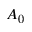Convert formula to latex. <formula><loc_0><loc_0><loc_500><loc_500>A _ { 0 }</formula> 